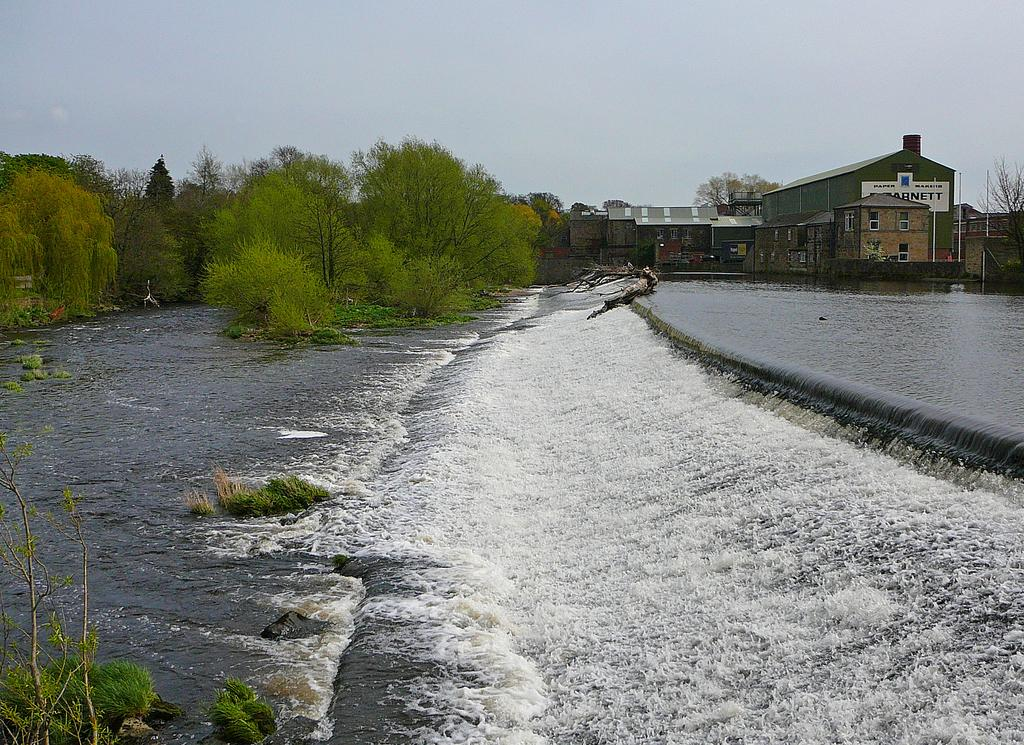What type of structures can be seen in the image? There are buildings in the image. What other natural elements are present in the image? There are trees in the image. Can you describe the water flow visible in the image? Yes, there is water flow visible in the image. What discovery was made in the image regarding a new substance? There is no mention of a discovery or a new substance in the image. 